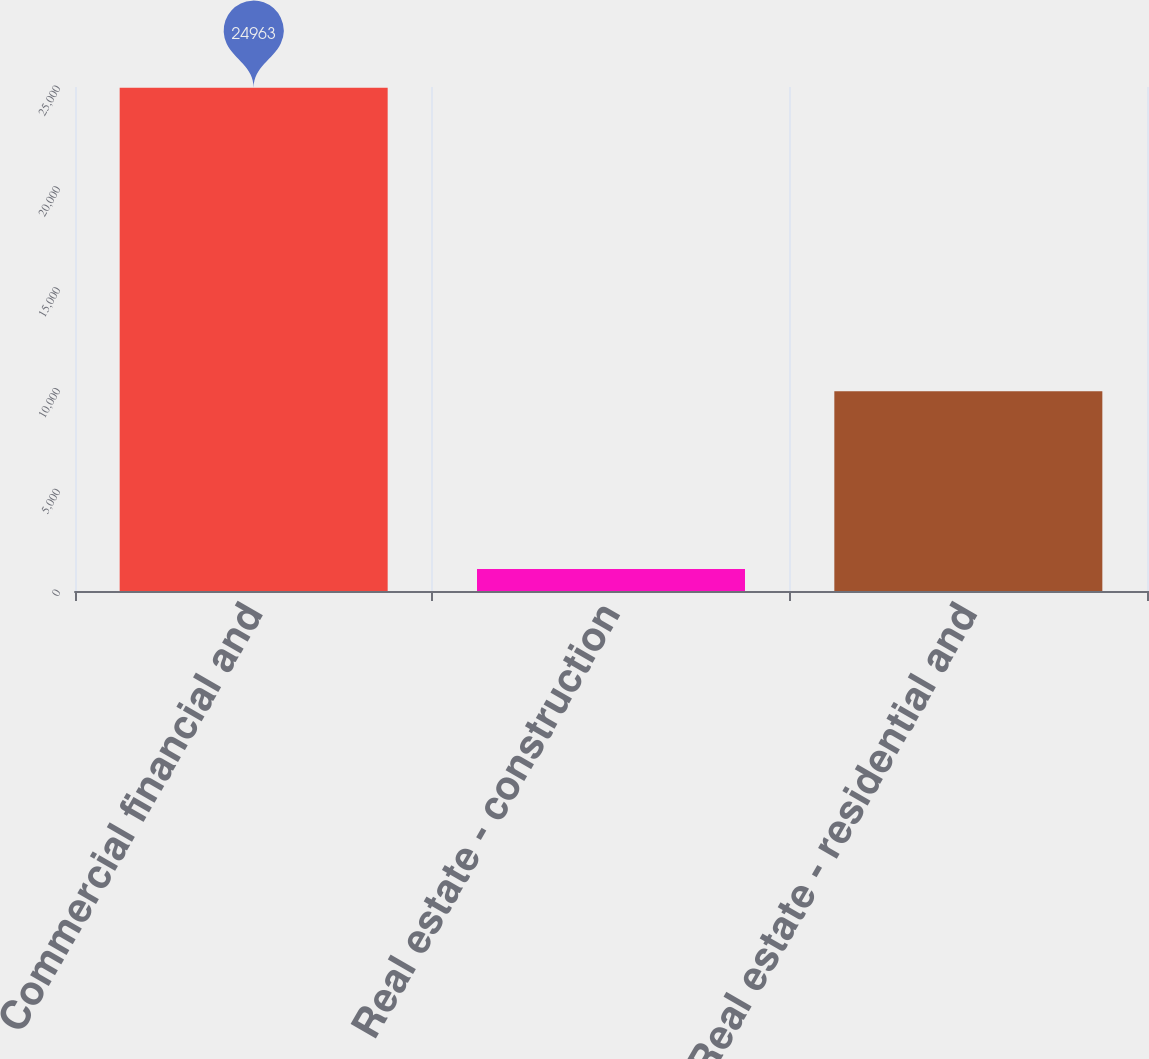Convert chart to OTSL. <chart><loc_0><loc_0><loc_500><loc_500><bar_chart><fcel>Commercial financial and<fcel>Real estate - construction<fcel>Real estate - residential and<nl><fcel>24963<fcel>1093<fcel>9907<nl></chart> 